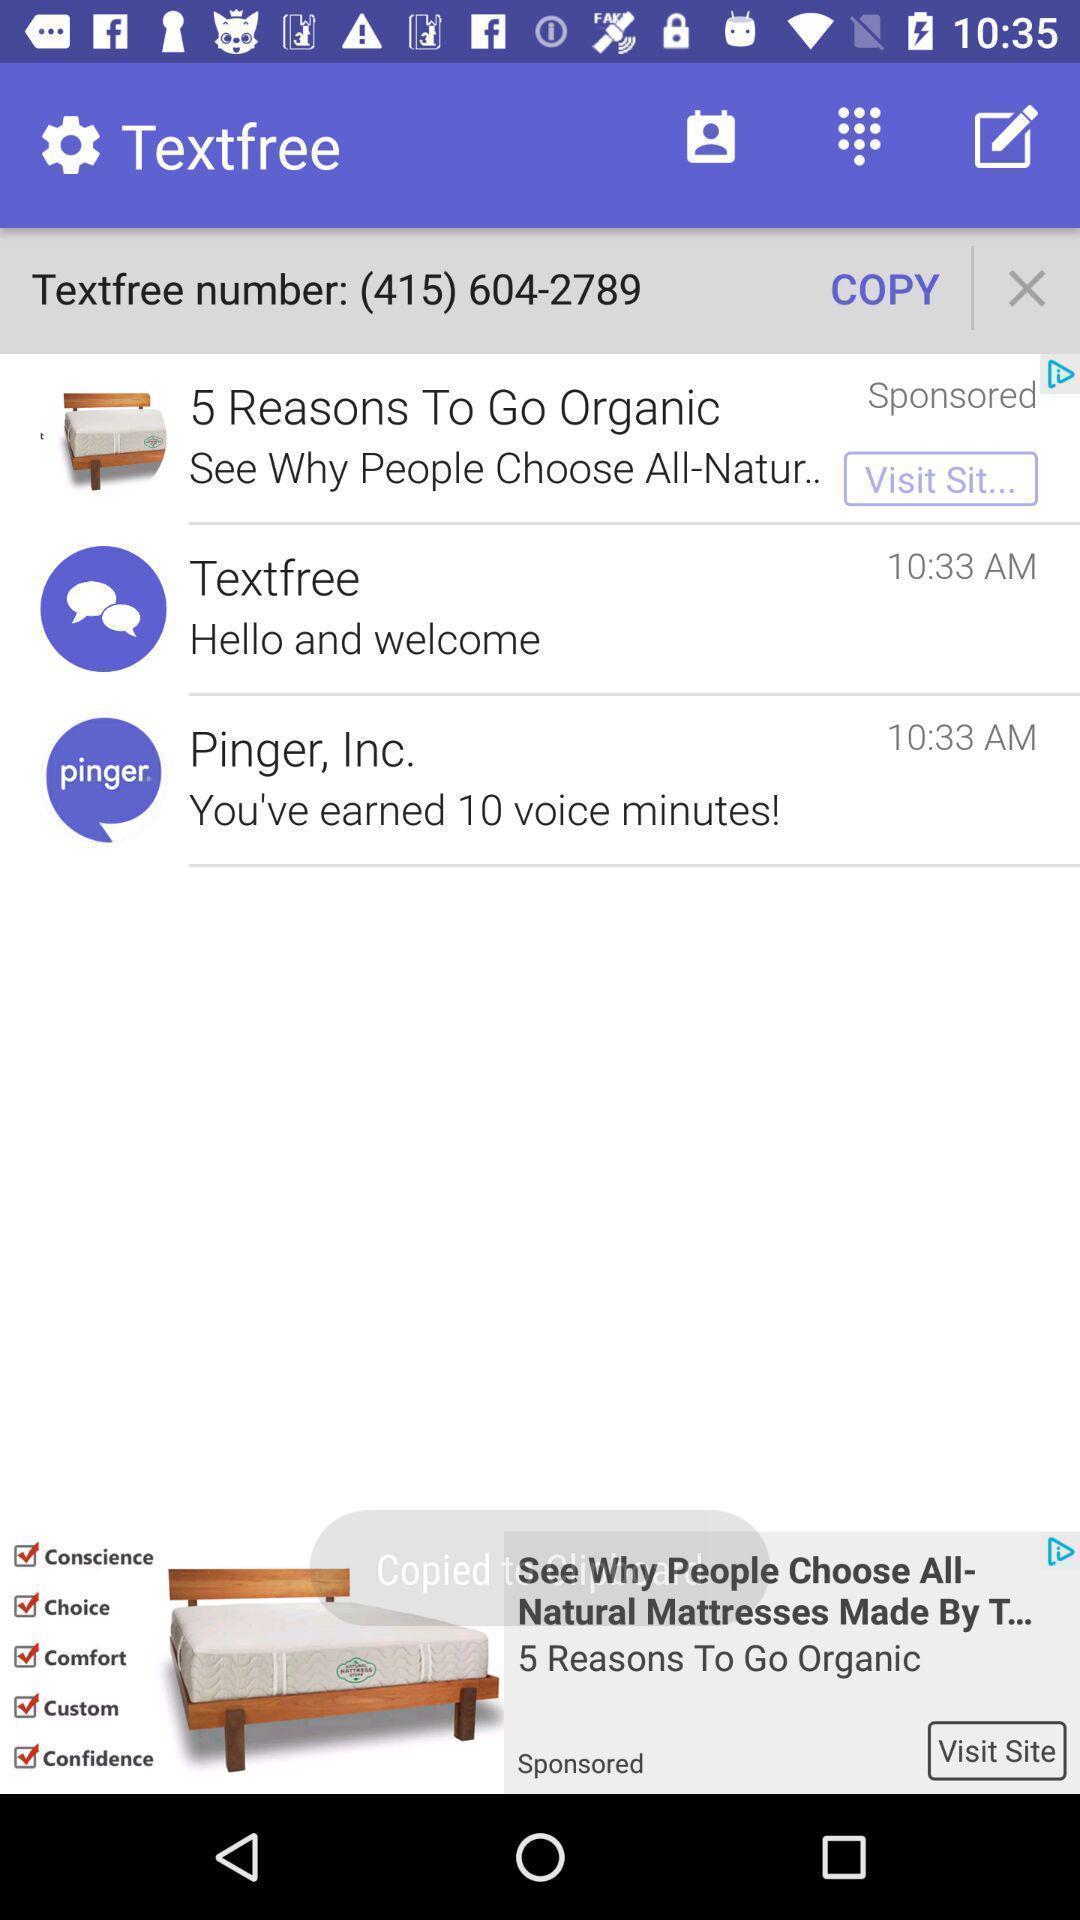Tell me about the visual elements in this screen capture. Screen shows multiple options in a chat application. 